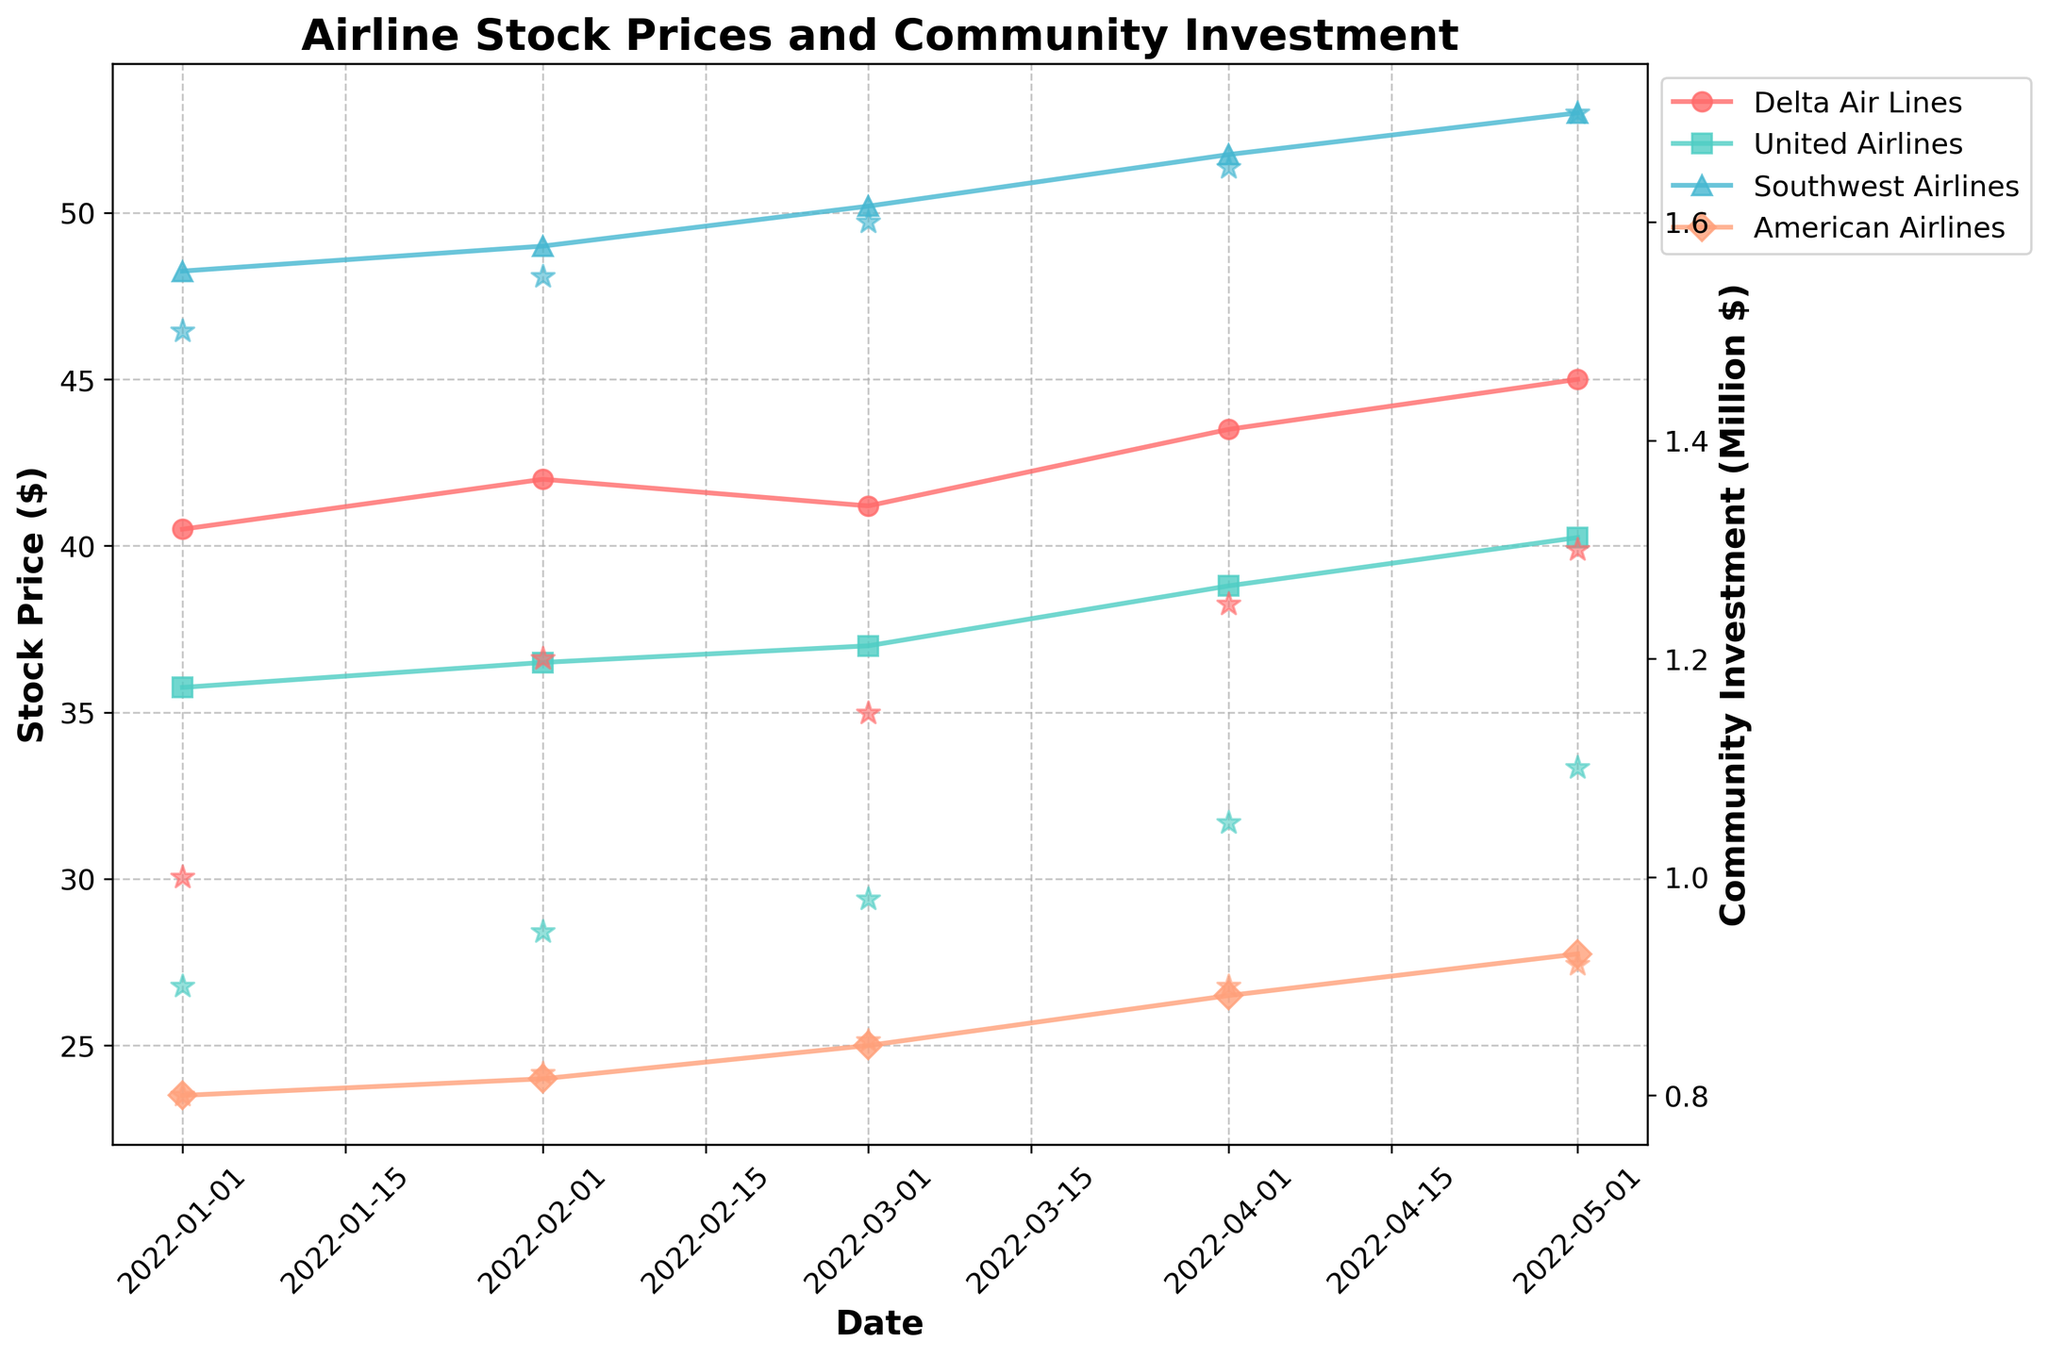What is the title of the figure? The title is located at the top of the figure in bold font.
Answer: Airline Stock Prices and Community Investment What are the x-axis and y-axis labels? The x-axis label is 'Date' and the y-axis labels are 'Stock Price ($)' on the left y-axis and 'Community Investment (Million $)' on the right y-axis.
Answer: Date, Stock Price ($), Community Investment (Million $) How many unique airlines are represented in the figure? Each unique airline has its own line and distinct markers in the plot.
Answer: Four Which airline had the highest stock price on May 1, 2022? By looking at the data points for May 1, 2022, and comparing the stock prices, we see that Southwest Airlines had the highest stock price.
Answer: Southwest Airlines How did Delta Air Lines' stock price change from January 2022 to May 2022? Check the data points for Delta Air Lines in January and May, and compare their stock prices (40.50 to 45.00).
Answer: Increased by $4.50 Which airline made the largest community investment in May 2022 and how much was it? Look at the star markers for May 2022 and the corresponding right y-axis value. Southwest Airlines has the highest investment of $1.7 million.
Answer: Southwest Airlines, $1.7 million What was the percentage increase in stock price for American Airlines from January 2022 to May 2022? Calculate the percentage increase: (27.75 - 23.50) / 23.50 * 100% = 18.09%
Answer: 18.09% Which airline had the steepest rise in stock price between April and May 2022? Compare the slopes of the lines for all airlines between April and May 2022; identify United Airlines.
Answer: United Airlines Is there any visible correlation between community investment and stock price for any airline over the period? Look for trends where both stock price and community investment amounts increase or decrease together; Southwest Airlines shows such correlation.
Answer: Yes, Southwest Airlines 